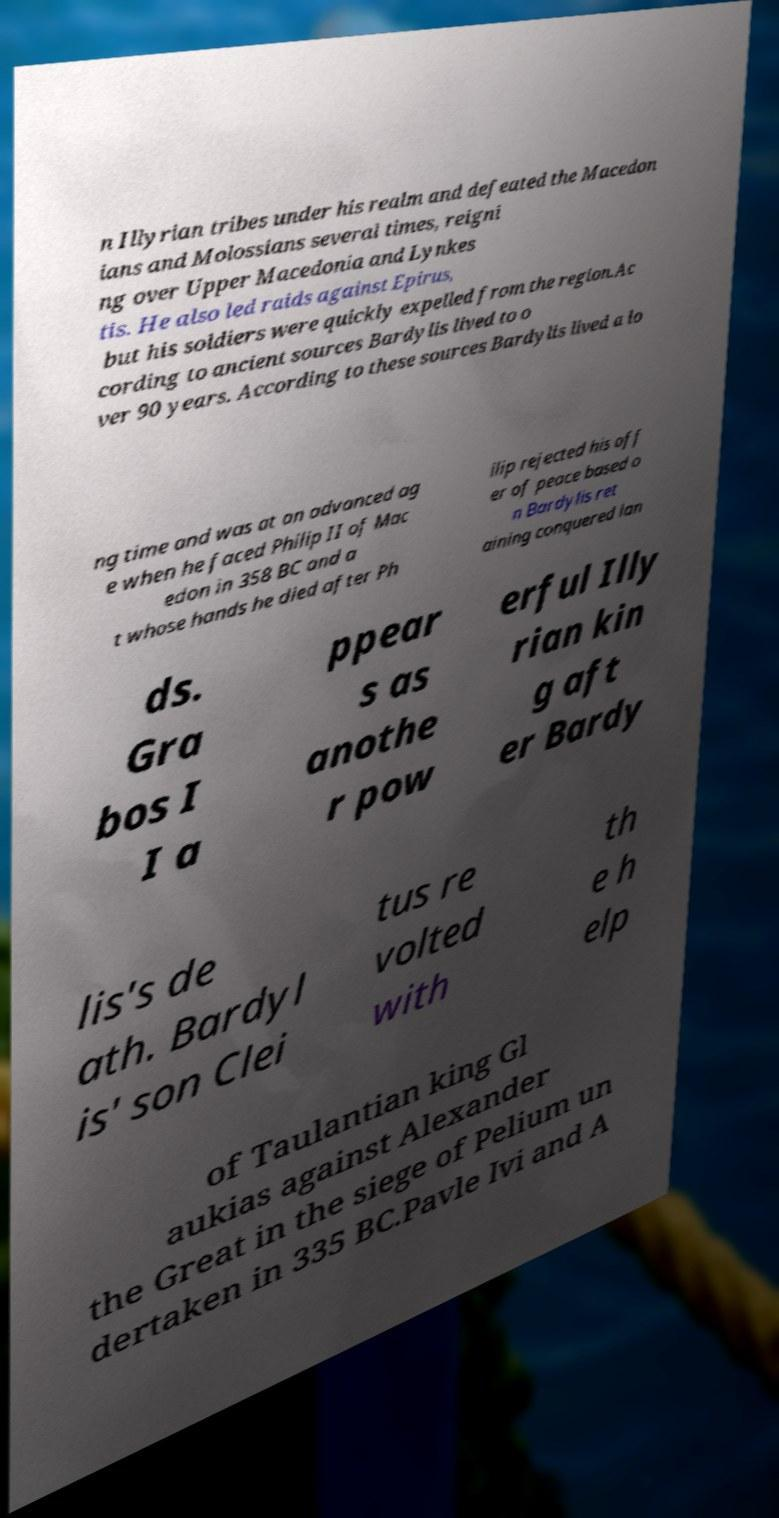Can you read and provide the text displayed in the image?This photo seems to have some interesting text. Can you extract and type it out for me? n Illyrian tribes under his realm and defeated the Macedon ians and Molossians several times, reigni ng over Upper Macedonia and Lynkes tis. He also led raids against Epirus, but his soldiers were quickly expelled from the region.Ac cording to ancient sources Bardylis lived to o ver 90 years. According to these sources Bardylis lived a lo ng time and was at an advanced ag e when he faced Philip II of Mac edon in 358 BC and a t whose hands he died after Ph ilip rejected his off er of peace based o n Bardylis ret aining conquered lan ds. Gra bos I I a ppear s as anothe r pow erful Illy rian kin g aft er Bardy lis's de ath. Bardyl is' son Clei tus re volted with th e h elp of Taulantian king Gl aukias against Alexander the Great in the siege of Pelium un dertaken in 335 BC.Pavle Ivi and A 